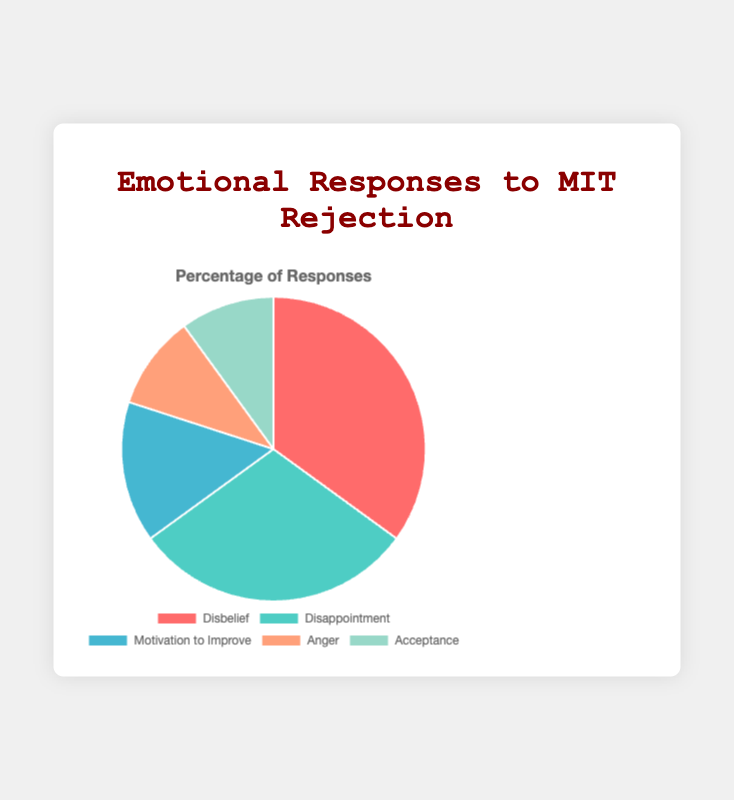How many total percentage points are assigned to feelings of 'Disbelief' and 'Disappointment'? To determine the total percentage points for 'Disbelief' and 'Disappointment', add their respective percentages: 35% + 30% = 65%
Answer: 65% What is the difference in percentage points between 'Disbelief' and 'Acceptance'? To find the difference between the 'Disbelief' and 'Acceptance' percentages, subtract 10% from 35%: 35% - 10% = 25%
Answer: 25% Which emotional response has the lowest representation in the chart? The chart shows that both 'Anger' and 'Acceptance' have a percentage of 10%, which is lower than the other responses. Therefore, both share the lowest representation.
Answer: Anger and Acceptance What are the two most prevalent emotional responses to rejection letters? The chart indicates that 'Disbelief' at 35% and 'Disappointment' at 30% are the two highest percentages. Therefore, they are the most prevalent responses.
Answer: Disbelief and Disappointment What percentage of responses is related to positive action ('Motivation to Improve' and 'Acceptance')? Adding the percentages for 'Motivation to Improve' (15%) and 'Acceptance' (10%): 15% + 10% = 25%
Answer: 25% Compare the percentages for 'Anger' and 'Motivation to Improve'. Which one is higher and by how much? 'Motivation to Improve' is at 15%, whereas 'Anger' is at 10%. The difference is 15% - 10% = 5%.
Answer: Motivation to Improve, by 5% What fraction of the total responses do 'Acceptance' and 'Anger' together represent? Combining the percentages of 'Acceptance' (10%) and 'Anger' (10%) and putting them over the total (100%): (10% + 10%) / 100% = 20% / 100% = 0.20
Answer: 0.20 Which emotional response is represented by a green color in the chart? By examining the chart's legend, 'Acceptance' is represented by a green color.
Answer: Acceptance Calculate the average percentage of 'Motivation to Improve', 'Anger', and 'Acceptance'. Add the percentages for 'Motivation to Improve' (15%), 'Anger' (10%), and 'Acceptance' (10%) and then divide by the number of responses: (15% + 10% + 10%) / 3 = 35% / 3 ≈ 11.67%
Answer: 11.67% 